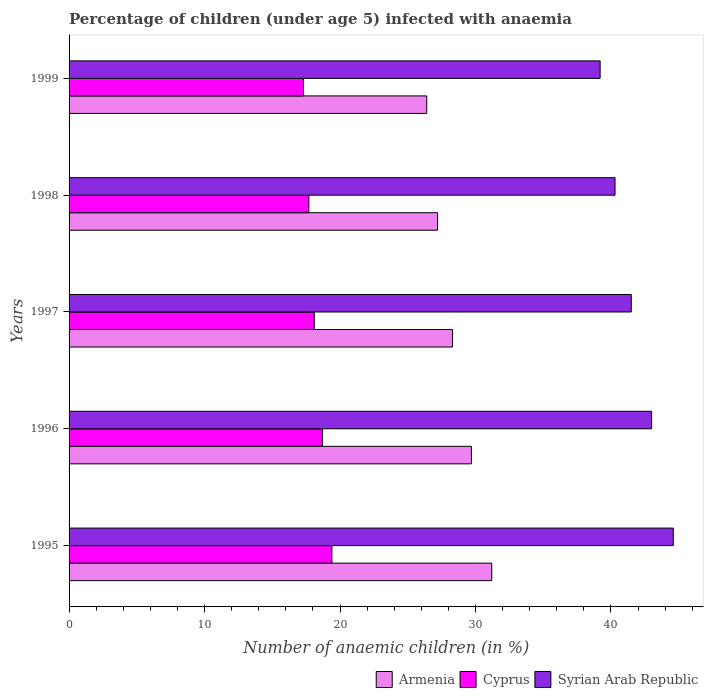How many groups of bars are there?
Your answer should be very brief. 5. What is the percentage of children infected with anaemia in in Cyprus in 1998?
Keep it short and to the point. 17.7. Across all years, what is the maximum percentage of children infected with anaemia in in Cyprus?
Offer a terse response. 19.4. Across all years, what is the minimum percentage of children infected with anaemia in in Syrian Arab Republic?
Ensure brevity in your answer.  39.2. In which year was the percentage of children infected with anaemia in in Armenia maximum?
Keep it short and to the point. 1995. In which year was the percentage of children infected with anaemia in in Syrian Arab Republic minimum?
Your answer should be compact. 1999. What is the total percentage of children infected with anaemia in in Syrian Arab Republic in the graph?
Offer a very short reply. 208.6. What is the difference between the percentage of children infected with anaemia in in Syrian Arab Republic in 1996 and that in 1998?
Provide a succinct answer. 2.7. What is the difference between the percentage of children infected with anaemia in in Armenia in 1998 and the percentage of children infected with anaemia in in Cyprus in 1999?
Offer a very short reply. 9.9. What is the average percentage of children infected with anaemia in in Armenia per year?
Provide a succinct answer. 28.56. In how many years, is the percentage of children infected with anaemia in in Armenia greater than 44 %?
Offer a very short reply. 0. What is the ratio of the percentage of children infected with anaemia in in Armenia in 1996 to that in 1999?
Your response must be concise. 1.12. Is the percentage of children infected with anaemia in in Syrian Arab Republic in 1995 less than that in 1998?
Offer a very short reply. No. What is the difference between the highest and the second highest percentage of children infected with anaemia in in Cyprus?
Your response must be concise. 0.7. What is the difference between the highest and the lowest percentage of children infected with anaemia in in Armenia?
Provide a succinct answer. 4.8. Is the sum of the percentage of children infected with anaemia in in Armenia in 1996 and 1998 greater than the maximum percentage of children infected with anaemia in in Cyprus across all years?
Provide a short and direct response. Yes. What does the 1st bar from the top in 1998 represents?
Ensure brevity in your answer.  Syrian Arab Republic. What does the 1st bar from the bottom in 1997 represents?
Make the answer very short. Armenia. How many bars are there?
Your answer should be very brief. 15. Are all the bars in the graph horizontal?
Give a very brief answer. Yes. Where does the legend appear in the graph?
Offer a very short reply. Bottom right. How many legend labels are there?
Give a very brief answer. 3. What is the title of the graph?
Give a very brief answer. Percentage of children (under age 5) infected with anaemia. What is the label or title of the X-axis?
Your answer should be compact. Number of anaemic children (in %). What is the Number of anaemic children (in %) of Armenia in 1995?
Ensure brevity in your answer.  31.2. What is the Number of anaemic children (in %) of Cyprus in 1995?
Provide a succinct answer. 19.4. What is the Number of anaemic children (in %) of Syrian Arab Republic in 1995?
Provide a succinct answer. 44.6. What is the Number of anaemic children (in %) of Armenia in 1996?
Your answer should be very brief. 29.7. What is the Number of anaemic children (in %) in Syrian Arab Republic in 1996?
Keep it short and to the point. 43. What is the Number of anaemic children (in %) of Armenia in 1997?
Keep it short and to the point. 28.3. What is the Number of anaemic children (in %) of Cyprus in 1997?
Offer a very short reply. 18.1. What is the Number of anaemic children (in %) of Syrian Arab Republic in 1997?
Your answer should be compact. 41.5. What is the Number of anaemic children (in %) in Armenia in 1998?
Your answer should be very brief. 27.2. What is the Number of anaemic children (in %) in Syrian Arab Republic in 1998?
Make the answer very short. 40.3. What is the Number of anaemic children (in %) in Armenia in 1999?
Offer a terse response. 26.4. What is the Number of anaemic children (in %) in Syrian Arab Republic in 1999?
Make the answer very short. 39.2. Across all years, what is the maximum Number of anaemic children (in %) in Armenia?
Offer a very short reply. 31.2. Across all years, what is the maximum Number of anaemic children (in %) in Cyprus?
Keep it short and to the point. 19.4. Across all years, what is the maximum Number of anaemic children (in %) of Syrian Arab Republic?
Your response must be concise. 44.6. Across all years, what is the minimum Number of anaemic children (in %) in Armenia?
Your answer should be compact. 26.4. Across all years, what is the minimum Number of anaemic children (in %) of Syrian Arab Republic?
Keep it short and to the point. 39.2. What is the total Number of anaemic children (in %) in Armenia in the graph?
Provide a succinct answer. 142.8. What is the total Number of anaemic children (in %) of Cyprus in the graph?
Make the answer very short. 91.2. What is the total Number of anaemic children (in %) of Syrian Arab Republic in the graph?
Your response must be concise. 208.6. What is the difference between the Number of anaemic children (in %) in Cyprus in 1995 and that in 1996?
Your answer should be very brief. 0.7. What is the difference between the Number of anaemic children (in %) in Syrian Arab Republic in 1995 and that in 1996?
Give a very brief answer. 1.6. What is the difference between the Number of anaemic children (in %) in Armenia in 1995 and that in 1997?
Offer a terse response. 2.9. What is the difference between the Number of anaemic children (in %) of Cyprus in 1995 and that in 1997?
Keep it short and to the point. 1.3. What is the difference between the Number of anaemic children (in %) in Syrian Arab Republic in 1995 and that in 1997?
Give a very brief answer. 3.1. What is the difference between the Number of anaemic children (in %) of Syrian Arab Republic in 1995 and that in 1998?
Your answer should be compact. 4.3. What is the difference between the Number of anaemic children (in %) in Cyprus in 1995 and that in 1999?
Ensure brevity in your answer.  2.1. What is the difference between the Number of anaemic children (in %) in Syrian Arab Republic in 1995 and that in 1999?
Keep it short and to the point. 5.4. What is the difference between the Number of anaemic children (in %) of Armenia in 1996 and that in 1997?
Make the answer very short. 1.4. What is the difference between the Number of anaemic children (in %) in Cyprus in 1996 and that in 1997?
Offer a terse response. 0.6. What is the difference between the Number of anaemic children (in %) of Armenia in 1996 and that in 1998?
Your answer should be very brief. 2.5. What is the difference between the Number of anaemic children (in %) in Syrian Arab Republic in 1996 and that in 1998?
Provide a succinct answer. 2.7. What is the difference between the Number of anaemic children (in %) in Cyprus in 1996 and that in 1999?
Your answer should be very brief. 1.4. What is the difference between the Number of anaemic children (in %) of Armenia in 1997 and that in 1998?
Your answer should be very brief. 1.1. What is the difference between the Number of anaemic children (in %) of Cyprus in 1997 and that in 1998?
Give a very brief answer. 0.4. What is the difference between the Number of anaemic children (in %) of Armenia in 1997 and that in 1999?
Provide a succinct answer. 1.9. What is the difference between the Number of anaemic children (in %) of Cyprus in 1997 and that in 1999?
Your answer should be very brief. 0.8. What is the difference between the Number of anaemic children (in %) in Syrian Arab Republic in 1997 and that in 1999?
Provide a short and direct response. 2.3. What is the difference between the Number of anaemic children (in %) of Cyprus in 1998 and that in 1999?
Make the answer very short. 0.4. What is the difference between the Number of anaemic children (in %) of Syrian Arab Republic in 1998 and that in 1999?
Provide a succinct answer. 1.1. What is the difference between the Number of anaemic children (in %) in Armenia in 1995 and the Number of anaemic children (in %) in Syrian Arab Republic in 1996?
Your response must be concise. -11.8. What is the difference between the Number of anaemic children (in %) in Cyprus in 1995 and the Number of anaemic children (in %) in Syrian Arab Republic in 1996?
Your answer should be very brief. -23.6. What is the difference between the Number of anaemic children (in %) in Armenia in 1995 and the Number of anaemic children (in %) in Cyprus in 1997?
Provide a succinct answer. 13.1. What is the difference between the Number of anaemic children (in %) of Cyprus in 1995 and the Number of anaemic children (in %) of Syrian Arab Republic in 1997?
Make the answer very short. -22.1. What is the difference between the Number of anaemic children (in %) of Armenia in 1995 and the Number of anaemic children (in %) of Cyprus in 1998?
Ensure brevity in your answer.  13.5. What is the difference between the Number of anaemic children (in %) in Cyprus in 1995 and the Number of anaemic children (in %) in Syrian Arab Republic in 1998?
Your response must be concise. -20.9. What is the difference between the Number of anaemic children (in %) in Armenia in 1995 and the Number of anaemic children (in %) in Cyprus in 1999?
Offer a very short reply. 13.9. What is the difference between the Number of anaemic children (in %) of Cyprus in 1995 and the Number of anaemic children (in %) of Syrian Arab Republic in 1999?
Keep it short and to the point. -19.8. What is the difference between the Number of anaemic children (in %) in Armenia in 1996 and the Number of anaemic children (in %) in Cyprus in 1997?
Your answer should be very brief. 11.6. What is the difference between the Number of anaemic children (in %) of Cyprus in 1996 and the Number of anaemic children (in %) of Syrian Arab Republic in 1997?
Ensure brevity in your answer.  -22.8. What is the difference between the Number of anaemic children (in %) in Armenia in 1996 and the Number of anaemic children (in %) in Cyprus in 1998?
Provide a succinct answer. 12. What is the difference between the Number of anaemic children (in %) of Armenia in 1996 and the Number of anaemic children (in %) of Syrian Arab Republic in 1998?
Provide a short and direct response. -10.6. What is the difference between the Number of anaemic children (in %) of Cyprus in 1996 and the Number of anaemic children (in %) of Syrian Arab Republic in 1998?
Your response must be concise. -21.6. What is the difference between the Number of anaemic children (in %) in Cyprus in 1996 and the Number of anaemic children (in %) in Syrian Arab Republic in 1999?
Offer a very short reply. -20.5. What is the difference between the Number of anaemic children (in %) in Armenia in 1997 and the Number of anaemic children (in %) in Cyprus in 1998?
Your answer should be very brief. 10.6. What is the difference between the Number of anaemic children (in %) in Armenia in 1997 and the Number of anaemic children (in %) in Syrian Arab Republic in 1998?
Your answer should be compact. -12. What is the difference between the Number of anaemic children (in %) of Cyprus in 1997 and the Number of anaemic children (in %) of Syrian Arab Republic in 1998?
Offer a very short reply. -22.2. What is the difference between the Number of anaemic children (in %) of Armenia in 1997 and the Number of anaemic children (in %) of Syrian Arab Republic in 1999?
Make the answer very short. -10.9. What is the difference between the Number of anaemic children (in %) in Cyprus in 1997 and the Number of anaemic children (in %) in Syrian Arab Republic in 1999?
Offer a very short reply. -21.1. What is the difference between the Number of anaemic children (in %) of Armenia in 1998 and the Number of anaemic children (in %) of Cyprus in 1999?
Keep it short and to the point. 9.9. What is the difference between the Number of anaemic children (in %) of Armenia in 1998 and the Number of anaemic children (in %) of Syrian Arab Republic in 1999?
Your response must be concise. -12. What is the difference between the Number of anaemic children (in %) of Cyprus in 1998 and the Number of anaemic children (in %) of Syrian Arab Republic in 1999?
Provide a succinct answer. -21.5. What is the average Number of anaemic children (in %) of Armenia per year?
Your answer should be compact. 28.56. What is the average Number of anaemic children (in %) in Cyprus per year?
Provide a succinct answer. 18.24. What is the average Number of anaemic children (in %) of Syrian Arab Republic per year?
Keep it short and to the point. 41.72. In the year 1995, what is the difference between the Number of anaemic children (in %) in Armenia and Number of anaemic children (in %) in Cyprus?
Offer a very short reply. 11.8. In the year 1995, what is the difference between the Number of anaemic children (in %) in Armenia and Number of anaemic children (in %) in Syrian Arab Republic?
Ensure brevity in your answer.  -13.4. In the year 1995, what is the difference between the Number of anaemic children (in %) in Cyprus and Number of anaemic children (in %) in Syrian Arab Republic?
Provide a succinct answer. -25.2. In the year 1996, what is the difference between the Number of anaemic children (in %) in Armenia and Number of anaemic children (in %) in Syrian Arab Republic?
Offer a terse response. -13.3. In the year 1996, what is the difference between the Number of anaemic children (in %) in Cyprus and Number of anaemic children (in %) in Syrian Arab Republic?
Make the answer very short. -24.3. In the year 1997, what is the difference between the Number of anaemic children (in %) of Armenia and Number of anaemic children (in %) of Cyprus?
Make the answer very short. 10.2. In the year 1997, what is the difference between the Number of anaemic children (in %) of Cyprus and Number of anaemic children (in %) of Syrian Arab Republic?
Your response must be concise. -23.4. In the year 1998, what is the difference between the Number of anaemic children (in %) in Armenia and Number of anaemic children (in %) in Cyprus?
Make the answer very short. 9.5. In the year 1998, what is the difference between the Number of anaemic children (in %) in Armenia and Number of anaemic children (in %) in Syrian Arab Republic?
Keep it short and to the point. -13.1. In the year 1998, what is the difference between the Number of anaemic children (in %) of Cyprus and Number of anaemic children (in %) of Syrian Arab Republic?
Provide a short and direct response. -22.6. In the year 1999, what is the difference between the Number of anaemic children (in %) in Armenia and Number of anaemic children (in %) in Syrian Arab Republic?
Your answer should be compact. -12.8. In the year 1999, what is the difference between the Number of anaemic children (in %) in Cyprus and Number of anaemic children (in %) in Syrian Arab Republic?
Your answer should be very brief. -21.9. What is the ratio of the Number of anaemic children (in %) in Armenia in 1995 to that in 1996?
Your answer should be very brief. 1.05. What is the ratio of the Number of anaemic children (in %) in Cyprus in 1995 to that in 1996?
Provide a short and direct response. 1.04. What is the ratio of the Number of anaemic children (in %) in Syrian Arab Republic in 1995 to that in 1996?
Your response must be concise. 1.04. What is the ratio of the Number of anaemic children (in %) of Armenia in 1995 to that in 1997?
Offer a very short reply. 1.1. What is the ratio of the Number of anaemic children (in %) of Cyprus in 1995 to that in 1997?
Your answer should be very brief. 1.07. What is the ratio of the Number of anaemic children (in %) in Syrian Arab Republic in 1995 to that in 1997?
Make the answer very short. 1.07. What is the ratio of the Number of anaemic children (in %) of Armenia in 1995 to that in 1998?
Keep it short and to the point. 1.15. What is the ratio of the Number of anaemic children (in %) in Cyprus in 1995 to that in 1998?
Provide a short and direct response. 1.1. What is the ratio of the Number of anaemic children (in %) in Syrian Arab Republic in 1995 to that in 1998?
Your response must be concise. 1.11. What is the ratio of the Number of anaemic children (in %) in Armenia in 1995 to that in 1999?
Offer a very short reply. 1.18. What is the ratio of the Number of anaemic children (in %) of Cyprus in 1995 to that in 1999?
Keep it short and to the point. 1.12. What is the ratio of the Number of anaemic children (in %) of Syrian Arab Republic in 1995 to that in 1999?
Your answer should be compact. 1.14. What is the ratio of the Number of anaemic children (in %) in Armenia in 1996 to that in 1997?
Offer a very short reply. 1.05. What is the ratio of the Number of anaemic children (in %) in Cyprus in 1996 to that in 1997?
Offer a terse response. 1.03. What is the ratio of the Number of anaemic children (in %) in Syrian Arab Republic in 1996 to that in 1997?
Your response must be concise. 1.04. What is the ratio of the Number of anaemic children (in %) of Armenia in 1996 to that in 1998?
Make the answer very short. 1.09. What is the ratio of the Number of anaemic children (in %) of Cyprus in 1996 to that in 1998?
Offer a terse response. 1.06. What is the ratio of the Number of anaemic children (in %) of Syrian Arab Republic in 1996 to that in 1998?
Keep it short and to the point. 1.07. What is the ratio of the Number of anaemic children (in %) of Armenia in 1996 to that in 1999?
Provide a succinct answer. 1.12. What is the ratio of the Number of anaemic children (in %) of Cyprus in 1996 to that in 1999?
Give a very brief answer. 1.08. What is the ratio of the Number of anaemic children (in %) of Syrian Arab Republic in 1996 to that in 1999?
Provide a succinct answer. 1.1. What is the ratio of the Number of anaemic children (in %) of Armenia in 1997 to that in 1998?
Provide a short and direct response. 1.04. What is the ratio of the Number of anaemic children (in %) of Cyprus in 1997 to that in 1998?
Your response must be concise. 1.02. What is the ratio of the Number of anaemic children (in %) of Syrian Arab Republic in 1997 to that in 1998?
Offer a terse response. 1.03. What is the ratio of the Number of anaemic children (in %) of Armenia in 1997 to that in 1999?
Your answer should be compact. 1.07. What is the ratio of the Number of anaemic children (in %) of Cyprus in 1997 to that in 1999?
Your answer should be very brief. 1.05. What is the ratio of the Number of anaemic children (in %) in Syrian Arab Republic in 1997 to that in 1999?
Your answer should be compact. 1.06. What is the ratio of the Number of anaemic children (in %) in Armenia in 1998 to that in 1999?
Ensure brevity in your answer.  1.03. What is the ratio of the Number of anaemic children (in %) in Cyprus in 1998 to that in 1999?
Your response must be concise. 1.02. What is the ratio of the Number of anaemic children (in %) of Syrian Arab Republic in 1998 to that in 1999?
Offer a terse response. 1.03. What is the difference between the highest and the second highest Number of anaemic children (in %) in Armenia?
Provide a succinct answer. 1.5. What is the difference between the highest and the second highest Number of anaemic children (in %) of Cyprus?
Keep it short and to the point. 0.7. What is the difference between the highest and the lowest Number of anaemic children (in %) in Syrian Arab Republic?
Your answer should be compact. 5.4. 